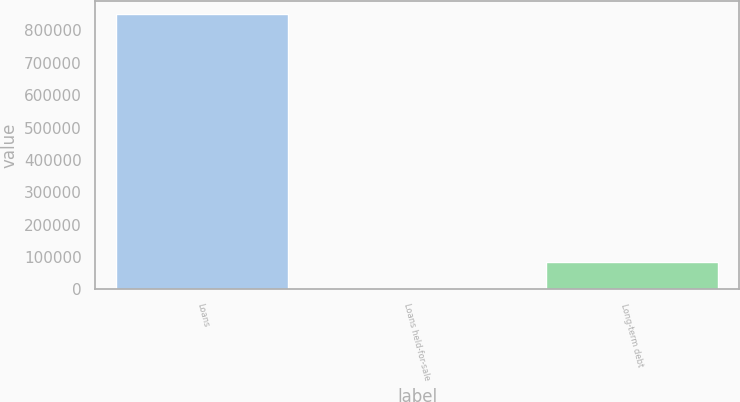<chart> <loc_0><loc_0><loc_500><loc_500><bar_chart><fcel>Loans<fcel>Loans held-for-sale<fcel>Long-term debt<nl><fcel>849576<fcel>909<fcel>85775.7<nl></chart> 